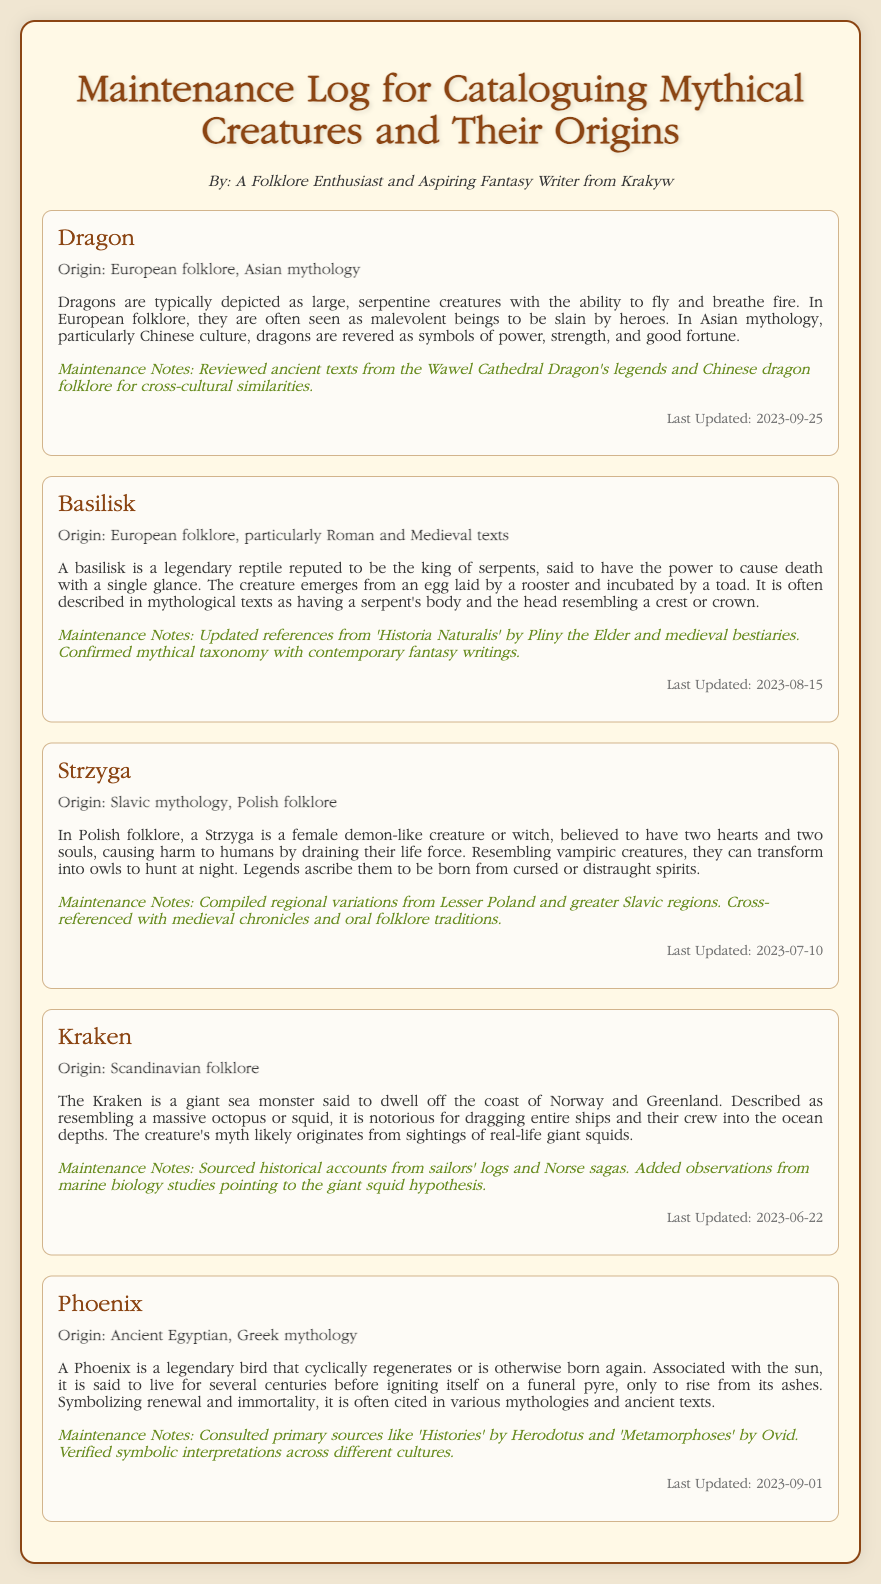what are the origins of the Dragon? The origins of the Dragon are mentioned as European folklore and Asian mythology.
Answer: European folklore, Asian mythology what creature is described as having two hearts and two souls? The creature with two hearts and two souls is the Strzyga, as per the description given.
Answer: Strzyga when was the last update for the Kraken? The last update for the Kraken was noted in the entry.
Answer: 2023-06-22 what is the primary source consulted for the Phoenix? The primary source consulted for the Phoenix is mentioned in the maintenance notes.
Answer: Histories how is the Basilisk said to kill? The Basilisk is said to cause death with a single glance, according to the description.
Answer: single glance what common theme is noted in the origins of the Phoenix? The origins of the Phoenix include a theme of renewal and immortality.
Answer: renewal and immortality which mythical creature is related to sailors' logs? The creature that is related to sailors' logs, as per maintenance notes, is the Kraken.
Answer: Kraken what type of mythology is the Strzyga associated with? The Strzyga is associated with Slavic mythology and Polish folklore.
Answer: Slavic mythology, Polish folklore what aspect of the Kraken was explored in marine biology studies? The updated maintenance notes mention a hypothesis regarding the giant squid, linked to the Kraken.
Answer: giant squid hypothesis 